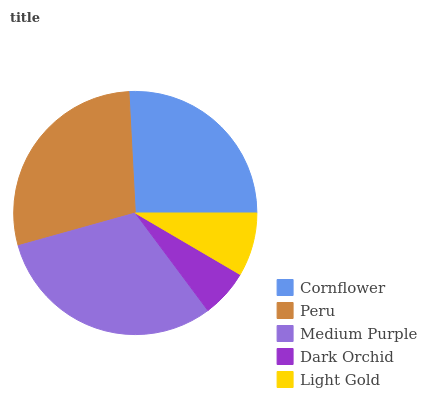Is Dark Orchid the minimum?
Answer yes or no. Yes. Is Medium Purple the maximum?
Answer yes or no. Yes. Is Peru the minimum?
Answer yes or no. No. Is Peru the maximum?
Answer yes or no. No. Is Peru greater than Cornflower?
Answer yes or no. Yes. Is Cornflower less than Peru?
Answer yes or no. Yes. Is Cornflower greater than Peru?
Answer yes or no. No. Is Peru less than Cornflower?
Answer yes or no. No. Is Cornflower the high median?
Answer yes or no. Yes. Is Cornflower the low median?
Answer yes or no. Yes. Is Dark Orchid the high median?
Answer yes or no. No. Is Dark Orchid the low median?
Answer yes or no. No. 